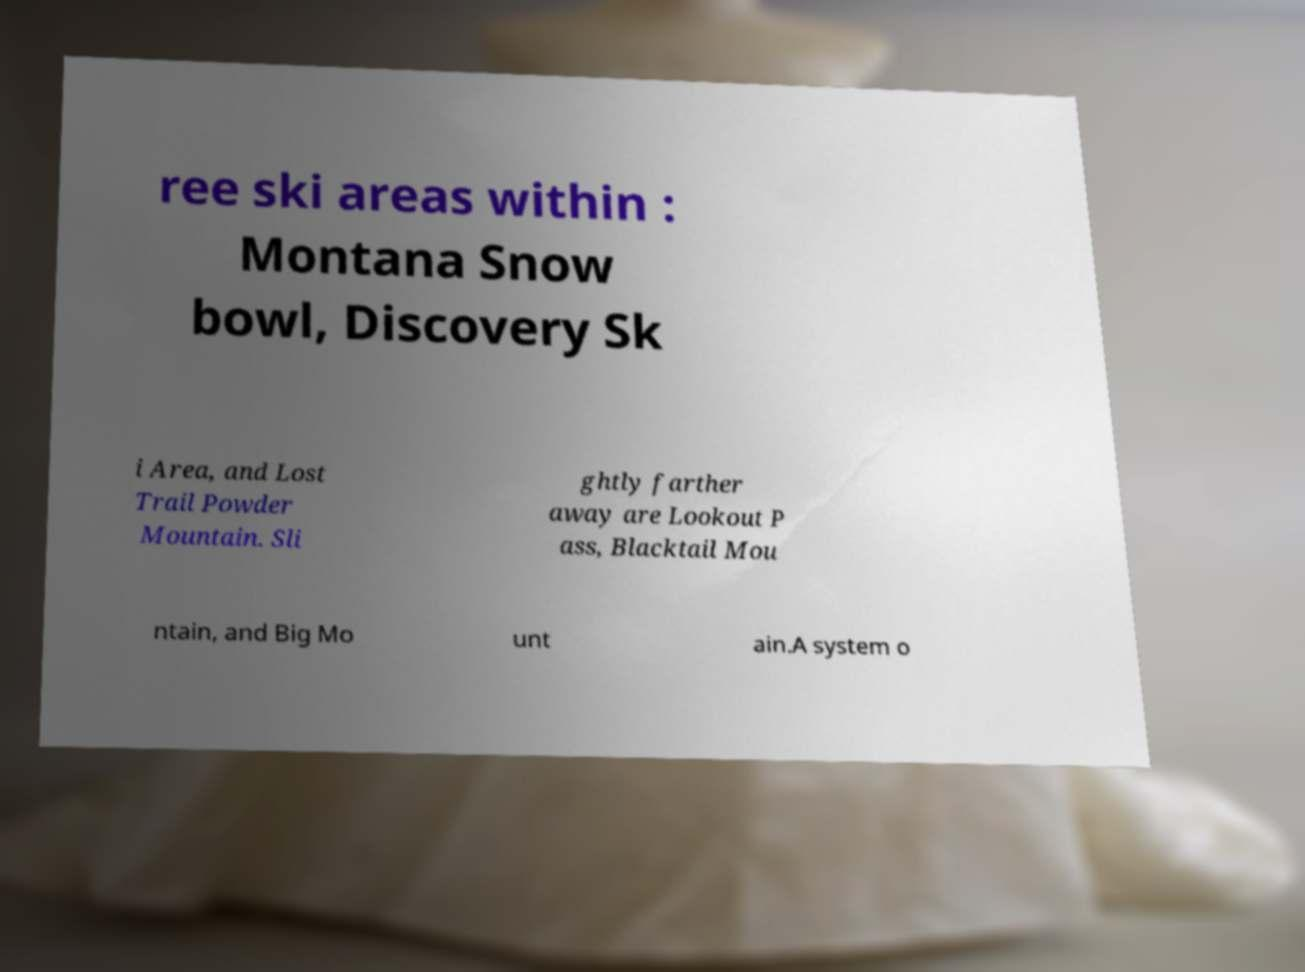Can you accurately transcribe the text from the provided image for me? ree ski areas within : Montana Snow bowl, Discovery Sk i Area, and Lost Trail Powder Mountain. Sli ghtly farther away are Lookout P ass, Blacktail Mou ntain, and Big Mo unt ain.A system o 